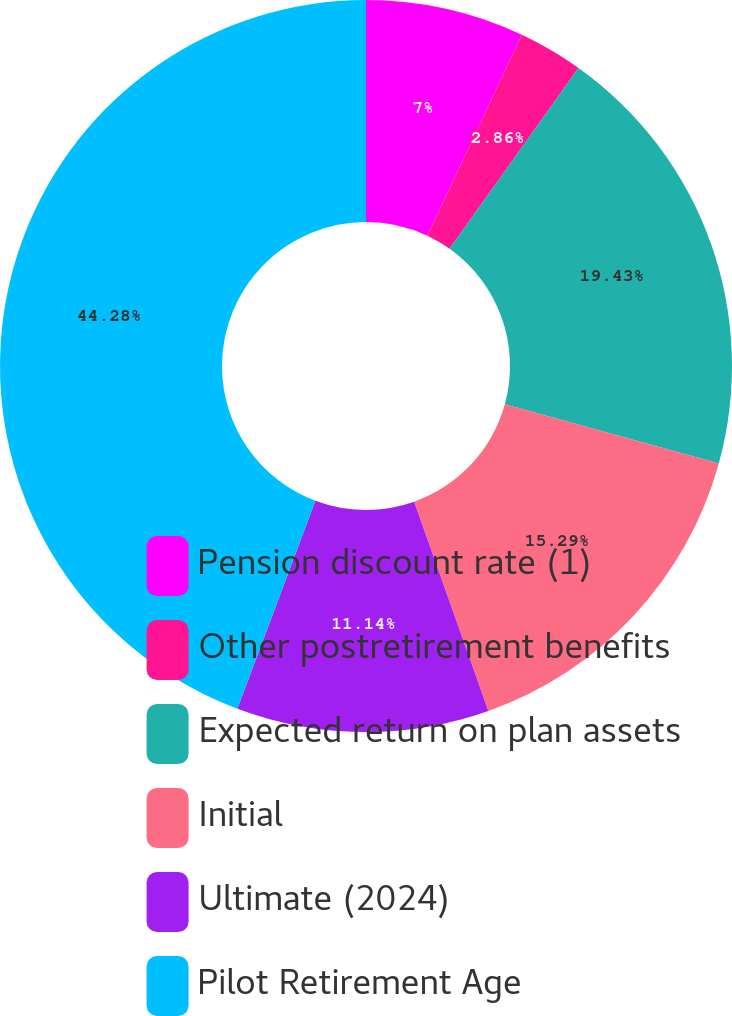<chart> <loc_0><loc_0><loc_500><loc_500><pie_chart><fcel>Pension discount rate (1)<fcel>Other postretirement benefits<fcel>Expected return on plan assets<fcel>Initial<fcel>Ultimate (2024)<fcel>Pilot Retirement Age<nl><fcel>7.0%<fcel>2.86%<fcel>19.43%<fcel>15.29%<fcel>11.14%<fcel>44.29%<nl></chart> 